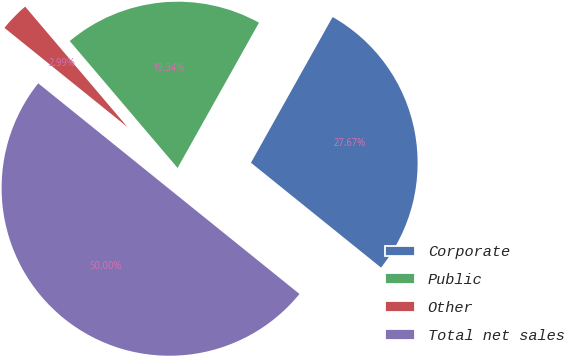<chart> <loc_0><loc_0><loc_500><loc_500><pie_chart><fcel>Corporate<fcel>Public<fcel>Other<fcel>Total net sales<nl><fcel>27.67%<fcel>19.34%<fcel>2.99%<fcel>50.0%<nl></chart> 